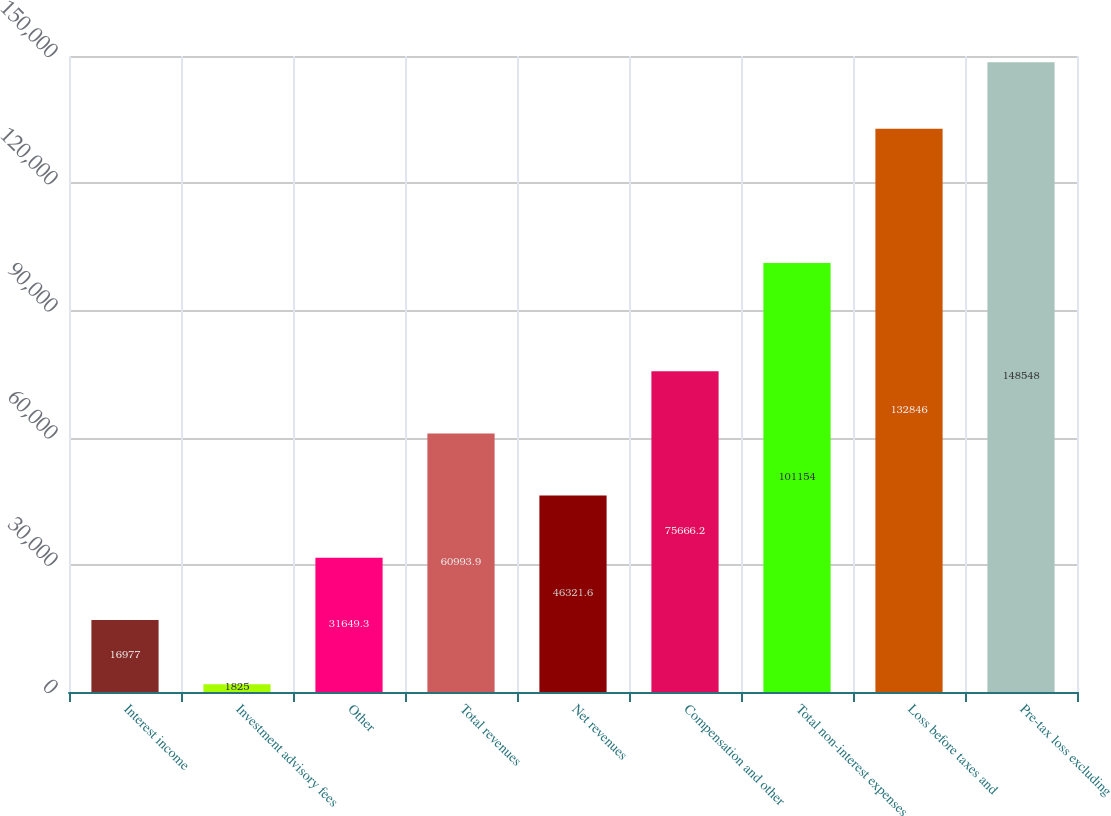Convert chart to OTSL. <chart><loc_0><loc_0><loc_500><loc_500><bar_chart><fcel>Interest income<fcel>Investment advisory fees<fcel>Other<fcel>Total revenues<fcel>Net revenues<fcel>Compensation and other<fcel>Total non-interest expenses<fcel>Loss before taxes and<fcel>Pre-tax loss excluding<nl><fcel>16977<fcel>1825<fcel>31649.3<fcel>60993.9<fcel>46321.6<fcel>75666.2<fcel>101154<fcel>132846<fcel>148548<nl></chart> 